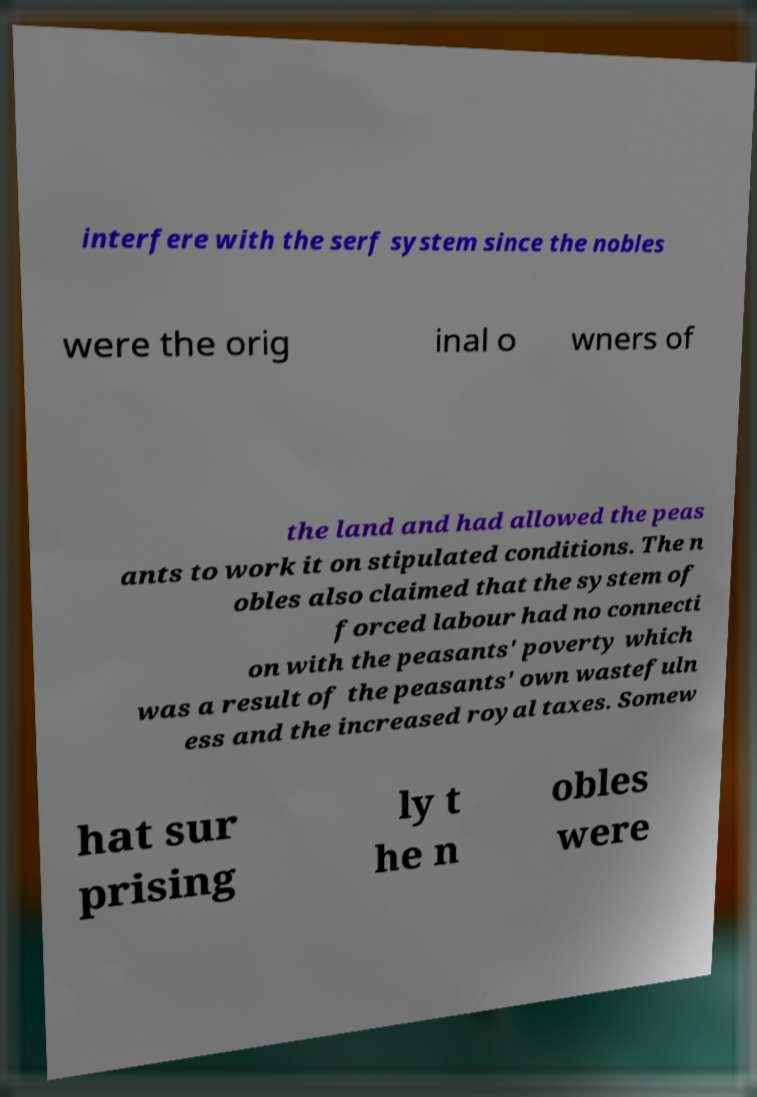Please identify and transcribe the text found in this image. interfere with the serf system since the nobles were the orig inal o wners of the land and had allowed the peas ants to work it on stipulated conditions. The n obles also claimed that the system of forced labour had no connecti on with the peasants' poverty which was a result of the peasants' own wastefuln ess and the increased royal taxes. Somew hat sur prising ly t he n obles were 